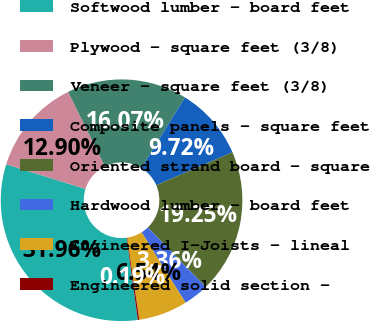<chart> <loc_0><loc_0><loc_500><loc_500><pie_chart><fcel>Softwood lumber - board feet<fcel>Plywood - square feet (3/8)<fcel>Veneer - square feet (3/8)<fcel>Composite panels - square feet<fcel>Oriented strand board - square<fcel>Hardwood lumber - board feet<fcel>Engineered I-Joists - lineal<fcel>Engineered solid section -<nl><fcel>31.96%<fcel>12.9%<fcel>16.07%<fcel>9.72%<fcel>19.25%<fcel>3.36%<fcel>6.54%<fcel>0.19%<nl></chart> 